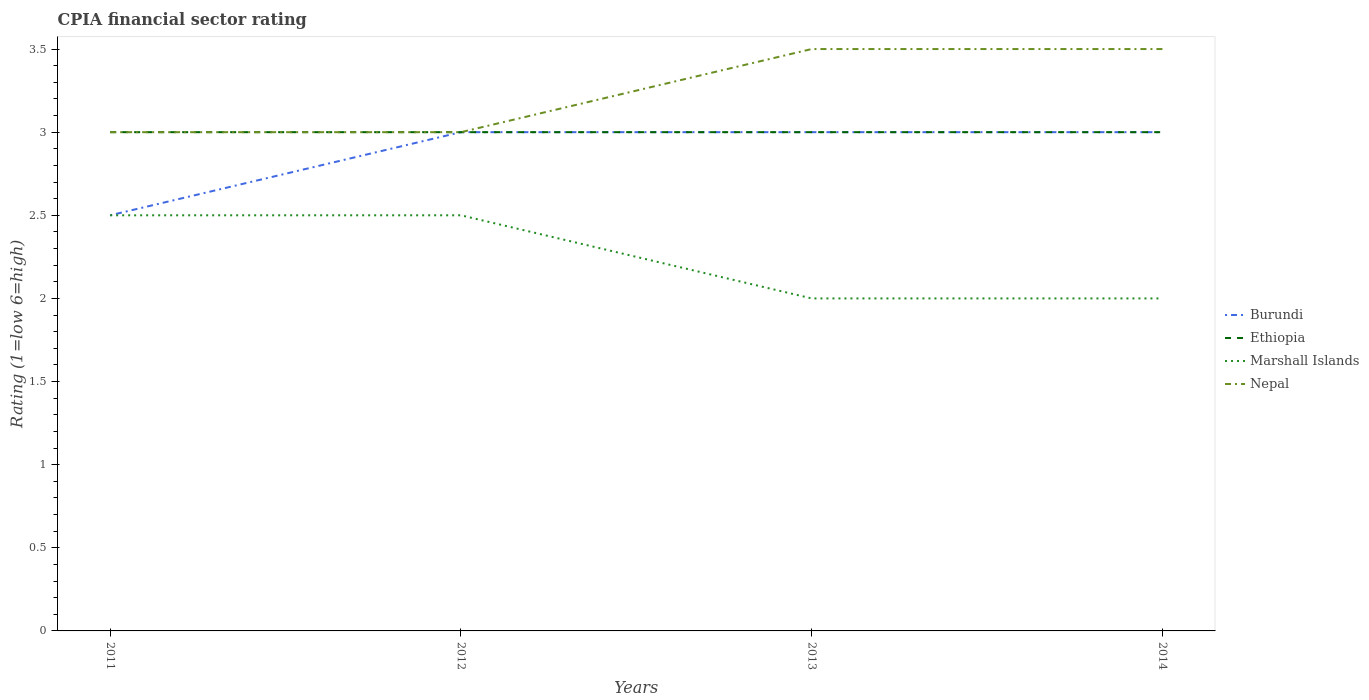Does the line corresponding to Burundi intersect with the line corresponding to Marshall Islands?
Your answer should be compact. Yes. Across all years, what is the maximum CPIA rating in Ethiopia?
Your answer should be very brief. 3. What is the total CPIA rating in Burundi in the graph?
Your answer should be compact. -0.5. What is the difference between the highest and the second highest CPIA rating in Nepal?
Offer a very short reply. 0.5. Is the CPIA rating in Marshall Islands strictly greater than the CPIA rating in Nepal over the years?
Provide a succinct answer. Yes. How many years are there in the graph?
Offer a terse response. 4. Are the values on the major ticks of Y-axis written in scientific E-notation?
Ensure brevity in your answer.  No. What is the title of the graph?
Offer a terse response. CPIA financial sector rating. Does "Paraguay" appear as one of the legend labels in the graph?
Ensure brevity in your answer.  No. What is the Rating (1=low 6=high) of Marshall Islands in 2011?
Your answer should be very brief. 2.5. What is the Rating (1=low 6=high) in Burundi in 2012?
Provide a short and direct response. 3. What is the Rating (1=low 6=high) in Ethiopia in 2012?
Keep it short and to the point. 3. What is the Rating (1=low 6=high) of Marshall Islands in 2012?
Provide a short and direct response. 2.5. What is the Rating (1=low 6=high) of Nepal in 2012?
Offer a terse response. 3. What is the Rating (1=low 6=high) in Burundi in 2013?
Your response must be concise. 3. What is the Rating (1=low 6=high) of Marshall Islands in 2013?
Your response must be concise. 2. What is the Rating (1=low 6=high) of Burundi in 2014?
Provide a succinct answer. 3. What is the Rating (1=low 6=high) in Ethiopia in 2014?
Offer a very short reply. 3. What is the Rating (1=low 6=high) of Marshall Islands in 2014?
Your response must be concise. 2. Across all years, what is the maximum Rating (1=low 6=high) of Ethiopia?
Give a very brief answer. 3. Across all years, what is the maximum Rating (1=low 6=high) of Marshall Islands?
Keep it short and to the point. 2.5. Across all years, what is the minimum Rating (1=low 6=high) in Burundi?
Your response must be concise. 2.5. Across all years, what is the minimum Rating (1=low 6=high) of Ethiopia?
Offer a very short reply. 3. What is the total Rating (1=low 6=high) in Marshall Islands in the graph?
Your response must be concise. 9. What is the difference between the Rating (1=low 6=high) of Burundi in 2011 and that in 2012?
Offer a very short reply. -0.5. What is the difference between the Rating (1=low 6=high) in Ethiopia in 2011 and that in 2012?
Ensure brevity in your answer.  0. What is the difference between the Rating (1=low 6=high) in Marshall Islands in 2011 and that in 2012?
Offer a very short reply. 0. What is the difference between the Rating (1=low 6=high) in Ethiopia in 2011 and that in 2013?
Your answer should be compact. 0. What is the difference between the Rating (1=low 6=high) in Marshall Islands in 2011 and that in 2013?
Give a very brief answer. 0.5. What is the difference between the Rating (1=low 6=high) in Ethiopia in 2011 and that in 2014?
Your response must be concise. 0. What is the difference between the Rating (1=low 6=high) of Marshall Islands in 2011 and that in 2014?
Provide a short and direct response. 0.5. What is the difference between the Rating (1=low 6=high) in Nepal in 2011 and that in 2014?
Provide a succinct answer. -0.5. What is the difference between the Rating (1=low 6=high) of Ethiopia in 2012 and that in 2013?
Ensure brevity in your answer.  0. What is the difference between the Rating (1=low 6=high) in Marshall Islands in 2012 and that in 2013?
Offer a very short reply. 0.5. What is the difference between the Rating (1=low 6=high) of Nepal in 2012 and that in 2013?
Make the answer very short. -0.5. What is the difference between the Rating (1=low 6=high) of Nepal in 2013 and that in 2014?
Ensure brevity in your answer.  0. What is the difference between the Rating (1=low 6=high) of Ethiopia in 2011 and the Rating (1=low 6=high) of Marshall Islands in 2012?
Make the answer very short. 0.5. What is the difference between the Rating (1=low 6=high) of Ethiopia in 2011 and the Rating (1=low 6=high) of Nepal in 2012?
Keep it short and to the point. 0. What is the difference between the Rating (1=low 6=high) of Marshall Islands in 2011 and the Rating (1=low 6=high) of Nepal in 2012?
Offer a very short reply. -0.5. What is the difference between the Rating (1=low 6=high) of Ethiopia in 2011 and the Rating (1=low 6=high) of Marshall Islands in 2013?
Keep it short and to the point. 1. What is the difference between the Rating (1=low 6=high) in Marshall Islands in 2011 and the Rating (1=low 6=high) in Nepal in 2013?
Provide a succinct answer. -1. What is the difference between the Rating (1=low 6=high) in Burundi in 2011 and the Rating (1=low 6=high) in Nepal in 2014?
Your response must be concise. -1. What is the difference between the Rating (1=low 6=high) of Marshall Islands in 2011 and the Rating (1=low 6=high) of Nepal in 2014?
Provide a succinct answer. -1. What is the difference between the Rating (1=low 6=high) of Burundi in 2012 and the Rating (1=low 6=high) of Ethiopia in 2013?
Give a very brief answer. 0. What is the difference between the Rating (1=low 6=high) in Burundi in 2012 and the Rating (1=low 6=high) in Marshall Islands in 2013?
Your answer should be very brief. 1. What is the difference between the Rating (1=low 6=high) of Ethiopia in 2012 and the Rating (1=low 6=high) of Marshall Islands in 2013?
Offer a very short reply. 1. What is the difference between the Rating (1=low 6=high) of Marshall Islands in 2012 and the Rating (1=low 6=high) of Nepal in 2013?
Your response must be concise. -1. What is the difference between the Rating (1=low 6=high) of Burundi in 2012 and the Rating (1=low 6=high) of Nepal in 2014?
Offer a terse response. -0.5. What is the difference between the Rating (1=low 6=high) in Ethiopia in 2012 and the Rating (1=low 6=high) in Nepal in 2014?
Ensure brevity in your answer.  -0.5. What is the difference between the Rating (1=low 6=high) of Ethiopia in 2013 and the Rating (1=low 6=high) of Marshall Islands in 2014?
Your answer should be very brief. 1. What is the difference between the Rating (1=low 6=high) of Marshall Islands in 2013 and the Rating (1=low 6=high) of Nepal in 2014?
Your response must be concise. -1.5. What is the average Rating (1=low 6=high) in Burundi per year?
Give a very brief answer. 2.88. What is the average Rating (1=low 6=high) in Ethiopia per year?
Make the answer very short. 3. What is the average Rating (1=low 6=high) in Marshall Islands per year?
Provide a short and direct response. 2.25. In the year 2011, what is the difference between the Rating (1=low 6=high) of Burundi and Rating (1=low 6=high) of Marshall Islands?
Your answer should be very brief. 0. In the year 2011, what is the difference between the Rating (1=low 6=high) of Burundi and Rating (1=low 6=high) of Nepal?
Offer a very short reply. -0.5. In the year 2011, what is the difference between the Rating (1=low 6=high) of Ethiopia and Rating (1=low 6=high) of Marshall Islands?
Your answer should be very brief. 0.5. In the year 2011, what is the difference between the Rating (1=low 6=high) of Ethiopia and Rating (1=low 6=high) of Nepal?
Keep it short and to the point. 0. In the year 2012, what is the difference between the Rating (1=low 6=high) of Burundi and Rating (1=low 6=high) of Ethiopia?
Give a very brief answer. 0. In the year 2012, what is the difference between the Rating (1=low 6=high) in Burundi and Rating (1=low 6=high) in Marshall Islands?
Ensure brevity in your answer.  0.5. In the year 2012, what is the difference between the Rating (1=low 6=high) of Burundi and Rating (1=low 6=high) of Nepal?
Give a very brief answer. 0. In the year 2012, what is the difference between the Rating (1=low 6=high) in Ethiopia and Rating (1=low 6=high) in Marshall Islands?
Your response must be concise. 0.5. In the year 2012, what is the difference between the Rating (1=low 6=high) in Marshall Islands and Rating (1=low 6=high) in Nepal?
Give a very brief answer. -0.5. In the year 2013, what is the difference between the Rating (1=low 6=high) in Burundi and Rating (1=low 6=high) in Ethiopia?
Provide a short and direct response. 0. In the year 2013, what is the difference between the Rating (1=low 6=high) in Burundi and Rating (1=low 6=high) in Nepal?
Offer a very short reply. -0.5. In the year 2013, what is the difference between the Rating (1=low 6=high) of Ethiopia and Rating (1=low 6=high) of Nepal?
Provide a succinct answer. -0.5. In the year 2014, what is the difference between the Rating (1=low 6=high) of Burundi and Rating (1=low 6=high) of Marshall Islands?
Provide a succinct answer. 1. What is the ratio of the Rating (1=low 6=high) of Ethiopia in 2011 to that in 2012?
Your response must be concise. 1. What is the ratio of the Rating (1=low 6=high) in Marshall Islands in 2011 to that in 2013?
Your response must be concise. 1.25. What is the ratio of the Rating (1=low 6=high) of Ethiopia in 2011 to that in 2014?
Your answer should be compact. 1. What is the ratio of the Rating (1=low 6=high) in Nepal in 2011 to that in 2014?
Your answer should be very brief. 0.86. What is the ratio of the Rating (1=low 6=high) of Marshall Islands in 2012 to that in 2014?
Your response must be concise. 1.25. What is the ratio of the Rating (1=low 6=high) in Nepal in 2012 to that in 2014?
Make the answer very short. 0.86. What is the ratio of the Rating (1=low 6=high) in Ethiopia in 2013 to that in 2014?
Offer a terse response. 1. What is the ratio of the Rating (1=low 6=high) in Marshall Islands in 2013 to that in 2014?
Your answer should be compact. 1. What is the difference between the highest and the second highest Rating (1=low 6=high) in Ethiopia?
Make the answer very short. 0. What is the difference between the highest and the lowest Rating (1=low 6=high) of Burundi?
Offer a very short reply. 0.5. What is the difference between the highest and the lowest Rating (1=low 6=high) of Ethiopia?
Offer a very short reply. 0. 